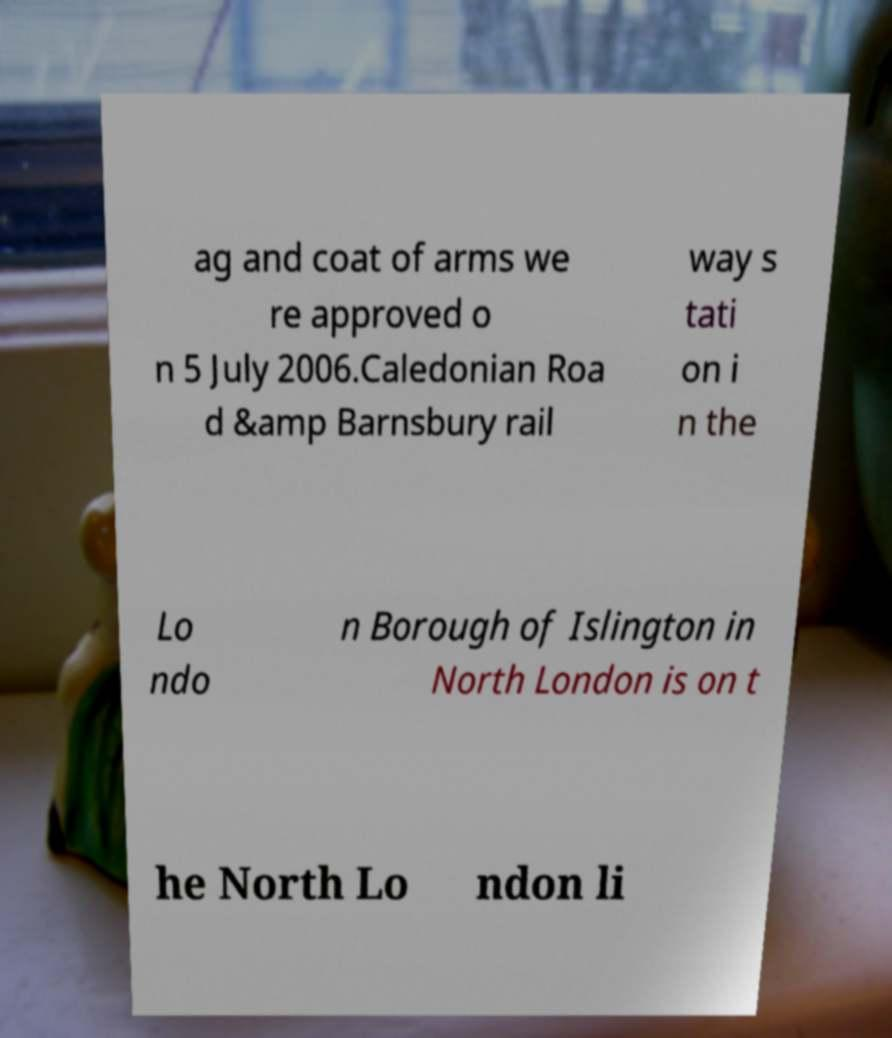Could you extract and type out the text from this image? ag and coat of arms we re approved o n 5 July 2006.Caledonian Roa d &amp Barnsbury rail way s tati on i n the Lo ndo n Borough of Islington in North London is on t he North Lo ndon li 